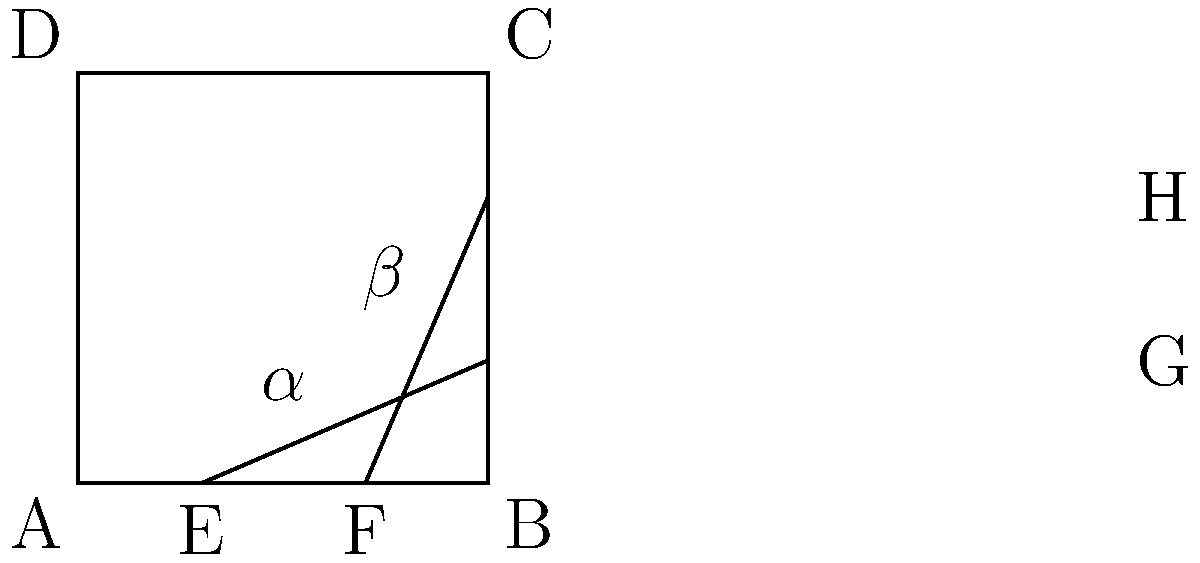In a professional tennis court, the singles sidelines intersect with the baseline at points E and F, as shown in the diagram. If angle $\alpha$ formed by line EG and the baseline is 26.5°, what is the measure of angle $\beta$ formed by line FH and the sideline BC? Let's approach this step-by-step:

1) First, recall that a tennis court is rectangular. This means that all four corners (A, B, C, D) are right angles (90°).

2) The lines EG and FH are parallel to each other, as they represent the singles sidelines.

3) When a line intersects two parallel lines, corresponding angles are equal. Therefore, angle $\alpha$ at point E is equal to the angle formed by line EG and side AD.

4) In a rectangle, adjacent angles are supplementary, meaning they add up to 180°. So, if we know angle $\alpha$, we can find the angle it forms with AD:

   $180° - 26.5° = 153.5°$

5) Now, consider the angle formed by FH and BC. This angle plus $\beta$ must equal 90° (as B is a right angle):

   $\beta + (180° - 153.5°) = 90°$

6) Simplifying:

   $\beta + 26.5° = 90°$

7) Solving for $\beta$:

   $\beta = 90° - 26.5° = 63.5°$

Therefore, angle $\beta$ measures 63.5°.
Answer: $63.5°$ 